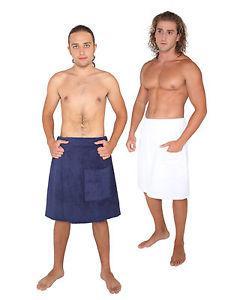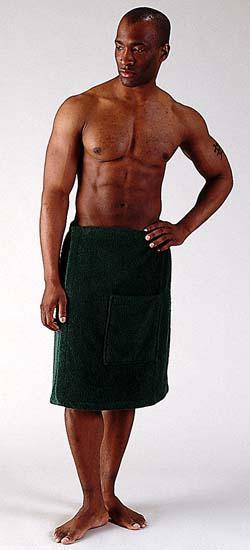The first image is the image on the left, the second image is the image on the right. Analyze the images presented: Is the assertion "Every photo shows exactly one shirtless man modeling one towel around his waist and the towels are not the same color." valid? Answer yes or no. No. 